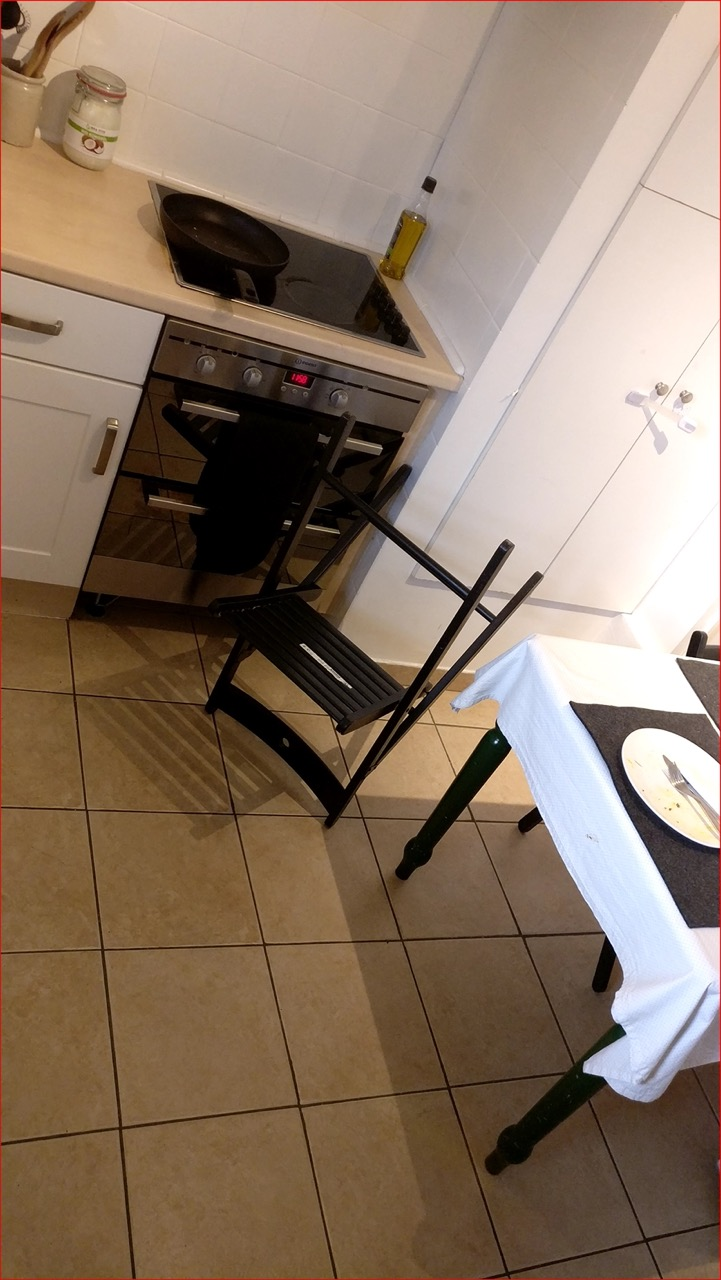Describe the style and condition of the kitchen shown in the image. The kitchen has a functional and compact design with white cabinetry and a tile backsplash. The floor is tiled, and there's a modern stove with a visible control panel indicating the temperature. The overall condition looks clean and well-maintained, though the space is somewhat cramped. 